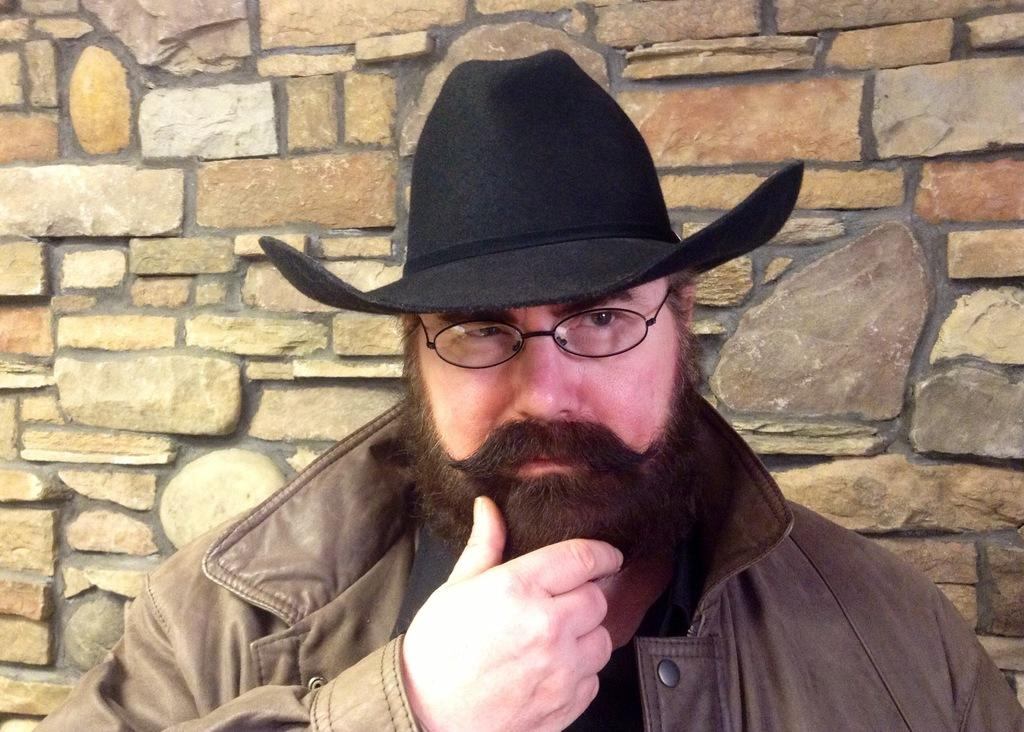Who is present in the image? There is a man in the image. What is the man wearing on his head? The man is wearing a hat. What type of eyewear is the man wearing? The man is wearing spectacles. What can be seen in the background of the image? There is a wall in the image. What type of room is the man standing in front of in the image? The provided facts do not mention a room or any specific location, so it cannot be determined from the image. 